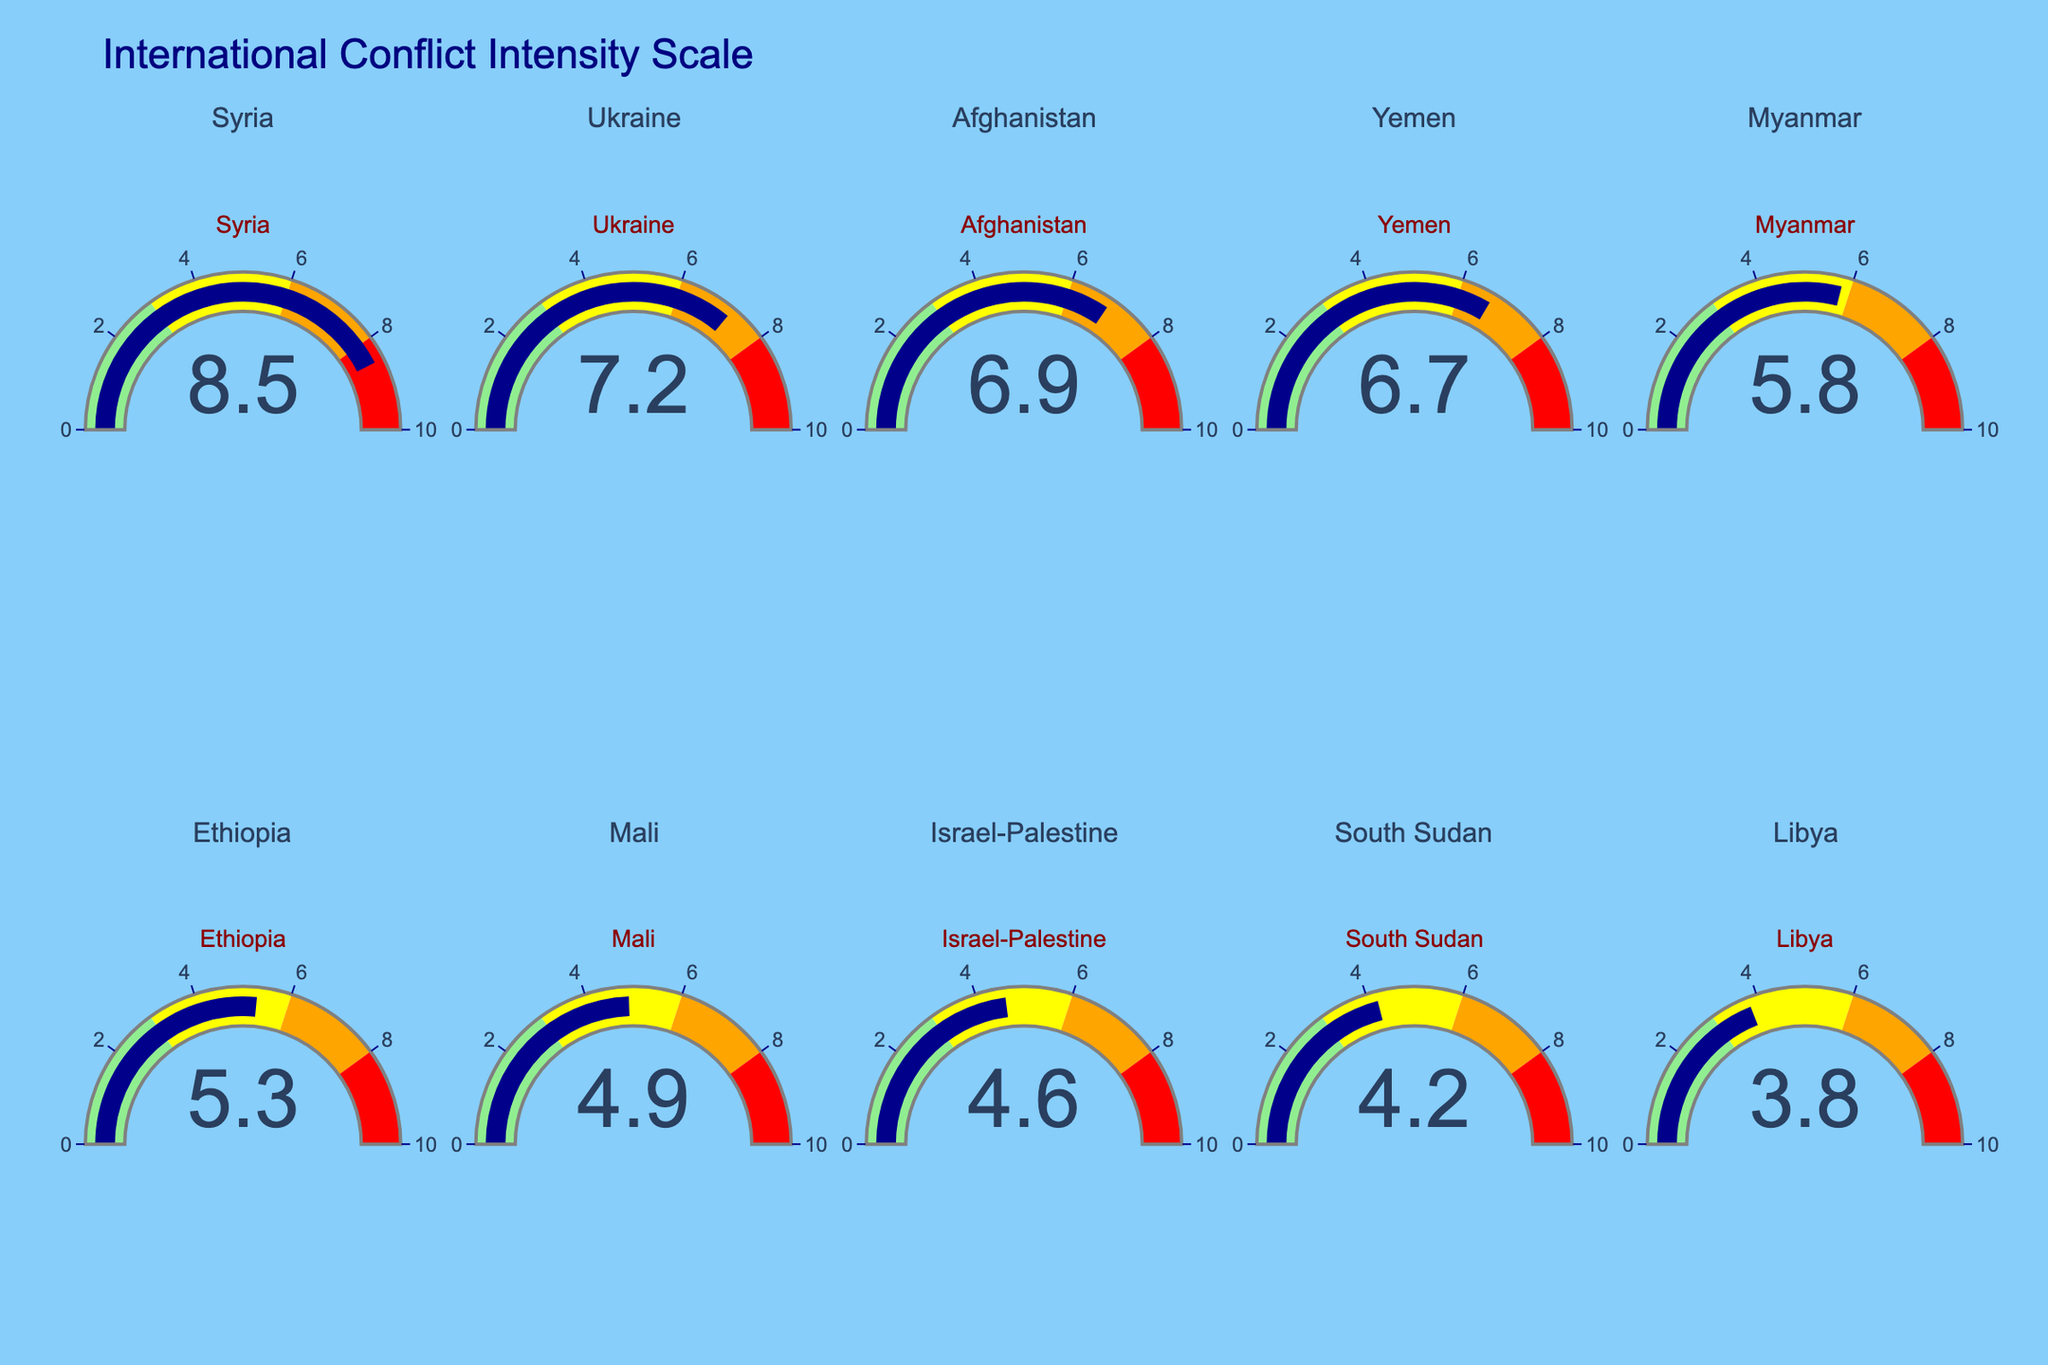What is the title of the figure? The title is usually displayed prominently at the top of the chart. In this case, the title is "International Conflict Intensity Scale".
Answer: International Conflict Intensity Scale What is the range of the gauge's intensity score axis? Each gauge's axis range represents the scale of conflict intensity. From the description, the range is from 0 to 10.
Answer: 0 to 10 Which conflict zone has the highest intensity score? By inspecting the gauges, Syria shows the highest intensity score with a value of 8.5.
Answer: Syria What are the gauge color indications from 0 to 10? The colors represent different intensity levels: light green (0-3), yellow (3-6), orange (6-8), and red (8-10).
Answer: Light green, yellow, orange, red What is the combined intensity score of Ukraine, Afghanistan, and Yemen? Add the intensity scores: Ukraine (7.2) + Afghanistan (6.9) + Yemen (6.7). The sum is 20.8.
Answer: 20.8 Which conflict zone has a lower intensity score: Myanmar or Ethiopia? Myanmar has an intensity score of 5.8, while Ethiopia has 5.3. Therefore, Ethiopia's score is lower.
Answer: Ethiopia How many conflict zones have an intensity score above 6? By counting the gauges with values above 6: Syria (8.5), Ukraine (7.2), Afghanistan (6.9), and Yemen (6.7). There are 4 conflict zones.
Answer: 4 Which zones fall into the yellow color range representing moderate intensity? Zones with scores between 3 and 6 fall into the yellow range: Myanmar (5.8), Ethiopia (5.3), Mali (4.9), Israel-Palestine (4.6), and South Sudan (4.2).
Answer: Myanmar, Ethiopia, Mali, Israel-Palestine, South Sudan What is the average intensity score of all listed conflict zones? Add all the intensity scores and divide by the number of zones. (8.5 + 7.2 + 6.9 + 6.7 + 5.8 + 5.3 + 4.9 + 4.6 + 4.2 + 3.8) / 10 = 57.9 / 10 = 5.79.
Answer: 5.79 Which conflict zones fall into the "high" and "very high" intensity categories (6-10)? Zones in the orange and red color ranges are: Syria (8.5, red), Ukraine (7.2, orange), Afghanistan (6.9, orange), and Yemen (6.7, orange).
Answer: Syria, Ukraine, Afghanistan, Yemen 